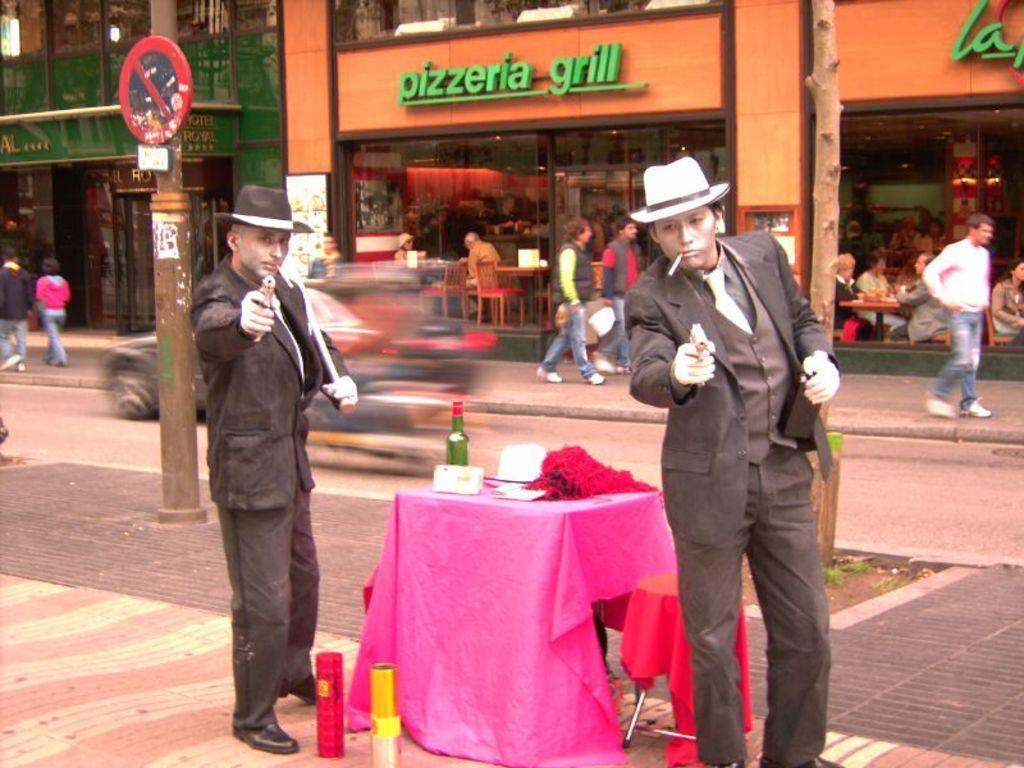Describe this image in one or two sentences. In this picture we can see two persons Standing and they are carrying a gun in between them they is a table placed which is covered with pink color cloth on the table we have Bottles And some flowers back of them there is a road some vehicles are moving and some people are walking beside the road we have shops some people sitting and eating. 